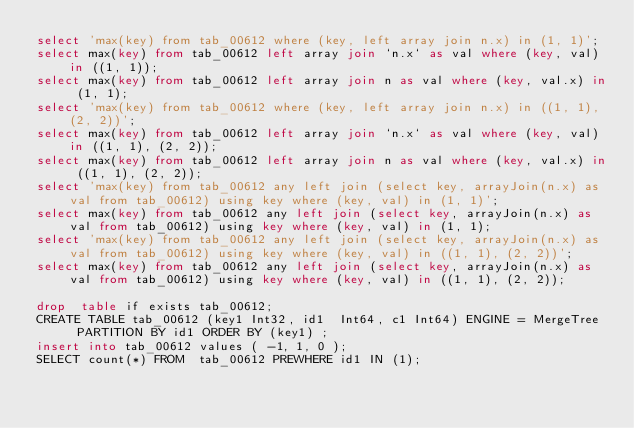Convert code to text. <code><loc_0><loc_0><loc_500><loc_500><_SQL_>select 'max(key) from tab_00612 where (key, left array join n.x) in (1, 1)';
select max(key) from tab_00612 left array join `n.x` as val where (key, val) in ((1, 1));
select max(key) from tab_00612 left array join n as val where (key, val.x) in (1, 1);
select 'max(key) from tab_00612 where (key, left array join n.x) in ((1, 1), (2, 2))';
select max(key) from tab_00612 left array join `n.x` as val where (key, val) in ((1, 1), (2, 2));
select max(key) from tab_00612 left array join n as val where (key, val.x) in ((1, 1), (2, 2));
select 'max(key) from tab_00612 any left join (select key, arrayJoin(n.x) as val from tab_00612) using key where (key, val) in (1, 1)';
select max(key) from tab_00612 any left join (select key, arrayJoin(n.x) as val from tab_00612) using key where (key, val) in (1, 1);
select 'max(key) from tab_00612 any left join (select key, arrayJoin(n.x) as val from tab_00612) using key where (key, val) in ((1, 1), (2, 2))';
select max(key) from tab_00612 any left join (select key, arrayJoin(n.x) as val from tab_00612) using key where (key, val) in ((1, 1), (2, 2));

drop  table if exists tab_00612;
CREATE TABLE tab_00612 (key1 Int32, id1  Int64, c1 Int64) ENGINE = MergeTree  PARTITION BY id1 ORDER BY (key1) ;
insert into tab_00612 values ( -1, 1, 0 );
SELECT count(*) FROM  tab_00612 PREWHERE id1 IN (1);
</code> 